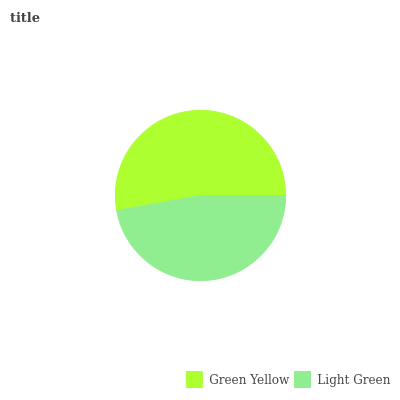Is Light Green the minimum?
Answer yes or no. Yes. Is Green Yellow the maximum?
Answer yes or no. Yes. Is Light Green the maximum?
Answer yes or no. No. Is Green Yellow greater than Light Green?
Answer yes or no. Yes. Is Light Green less than Green Yellow?
Answer yes or no. Yes. Is Light Green greater than Green Yellow?
Answer yes or no. No. Is Green Yellow less than Light Green?
Answer yes or no. No. Is Green Yellow the high median?
Answer yes or no. Yes. Is Light Green the low median?
Answer yes or no. Yes. Is Light Green the high median?
Answer yes or no. No. Is Green Yellow the low median?
Answer yes or no. No. 